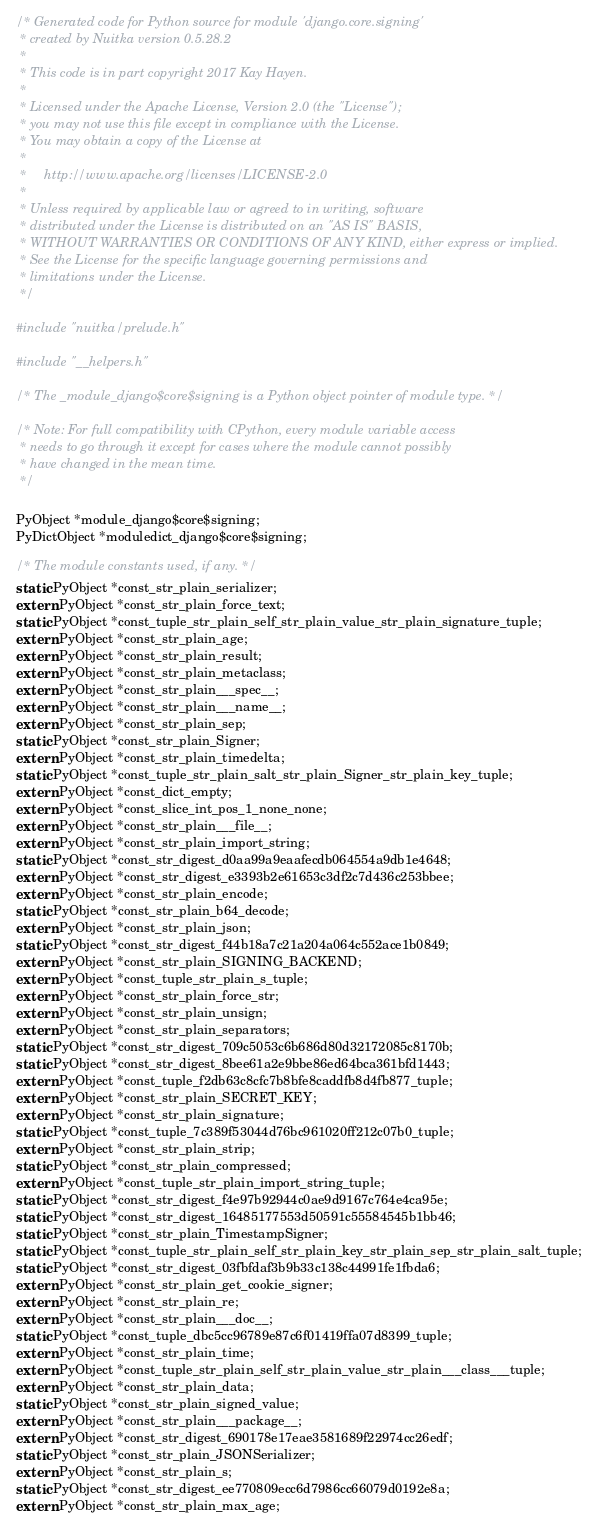Convert code to text. <code><loc_0><loc_0><loc_500><loc_500><_C++_>/* Generated code for Python source for module 'django.core.signing'
 * created by Nuitka version 0.5.28.2
 *
 * This code is in part copyright 2017 Kay Hayen.
 *
 * Licensed under the Apache License, Version 2.0 (the "License");
 * you may not use this file except in compliance with the License.
 * You may obtain a copy of the License at
 *
 *     http://www.apache.org/licenses/LICENSE-2.0
 *
 * Unless required by applicable law or agreed to in writing, software
 * distributed under the License is distributed on an "AS IS" BASIS,
 * WITHOUT WARRANTIES OR CONDITIONS OF ANY KIND, either express or implied.
 * See the License for the specific language governing permissions and
 * limitations under the License.
 */

#include "nuitka/prelude.h"

#include "__helpers.h"

/* The _module_django$core$signing is a Python object pointer of module type. */

/* Note: For full compatibility with CPython, every module variable access
 * needs to go through it except for cases where the module cannot possibly
 * have changed in the mean time.
 */

PyObject *module_django$core$signing;
PyDictObject *moduledict_django$core$signing;

/* The module constants used, if any. */
static PyObject *const_str_plain_serializer;
extern PyObject *const_str_plain_force_text;
static PyObject *const_tuple_str_plain_self_str_plain_value_str_plain_signature_tuple;
extern PyObject *const_str_plain_age;
extern PyObject *const_str_plain_result;
extern PyObject *const_str_plain_metaclass;
extern PyObject *const_str_plain___spec__;
extern PyObject *const_str_plain___name__;
extern PyObject *const_str_plain_sep;
static PyObject *const_str_plain_Signer;
extern PyObject *const_str_plain_timedelta;
static PyObject *const_tuple_str_plain_salt_str_plain_Signer_str_plain_key_tuple;
extern PyObject *const_dict_empty;
extern PyObject *const_slice_int_pos_1_none_none;
extern PyObject *const_str_plain___file__;
extern PyObject *const_str_plain_import_string;
static PyObject *const_str_digest_d0aa99a9eaafecdb064554a9db1e4648;
extern PyObject *const_str_digest_e3393b2e61653c3df2c7d436c253bbee;
extern PyObject *const_str_plain_encode;
static PyObject *const_str_plain_b64_decode;
extern PyObject *const_str_plain_json;
static PyObject *const_str_digest_f44b18a7c21a204a064c552ace1b0849;
extern PyObject *const_str_plain_SIGNING_BACKEND;
extern PyObject *const_tuple_str_plain_s_tuple;
extern PyObject *const_str_plain_force_str;
extern PyObject *const_str_plain_unsign;
extern PyObject *const_str_plain_separators;
static PyObject *const_str_digest_709c5053c6b686d80d32172085c8170b;
static PyObject *const_str_digest_8bee61a2e9bbe86ed64bca361bfd1443;
extern PyObject *const_tuple_f2db63c8cfc7b8bfe8caddfb8d4fb877_tuple;
extern PyObject *const_str_plain_SECRET_KEY;
extern PyObject *const_str_plain_signature;
static PyObject *const_tuple_7c389f53044d76bc961020ff212c07b0_tuple;
extern PyObject *const_str_plain_strip;
static PyObject *const_str_plain_compressed;
extern PyObject *const_tuple_str_plain_import_string_tuple;
static PyObject *const_str_digest_f4e97b92944c0ae9d9167c764e4ca95e;
static PyObject *const_str_digest_16485177553d50591c55584545b1bb46;
static PyObject *const_str_plain_TimestampSigner;
static PyObject *const_tuple_str_plain_self_str_plain_key_str_plain_sep_str_plain_salt_tuple;
static PyObject *const_str_digest_03fbfdaf3b9b33c138c44991fe1fbda6;
extern PyObject *const_str_plain_get_cookie_signer;
extern PyObject *const_str_plain_re;
extern PyObject *const_str_plain___doc__;
static PyObject *const_tuple_dbc5cc96789e87c6f01419ffa07d8399_tuple;
extern PyObject *const_str_plain_time;
extern PyObject *const_tuple_str_plain_self_str_plain_value_str_plain___class___tuple;
extern PyObject *const_str_plain_data;
static PyObject *const_str_plain_signed_value;
extern PyObject *const_str_plain___package__;
extern PyObject *const_str_digest_690178e17eae3581689f22974cc26edf;
static PyObject *const_str_plain_JSONSerializer;
extern PyObject *const_str_plain_s;
static PyObject *const_str_digest_ee770809ecc6d7986cc66079d0192e8a;
extern PyObject *const_str_plain_max_age;</code> 